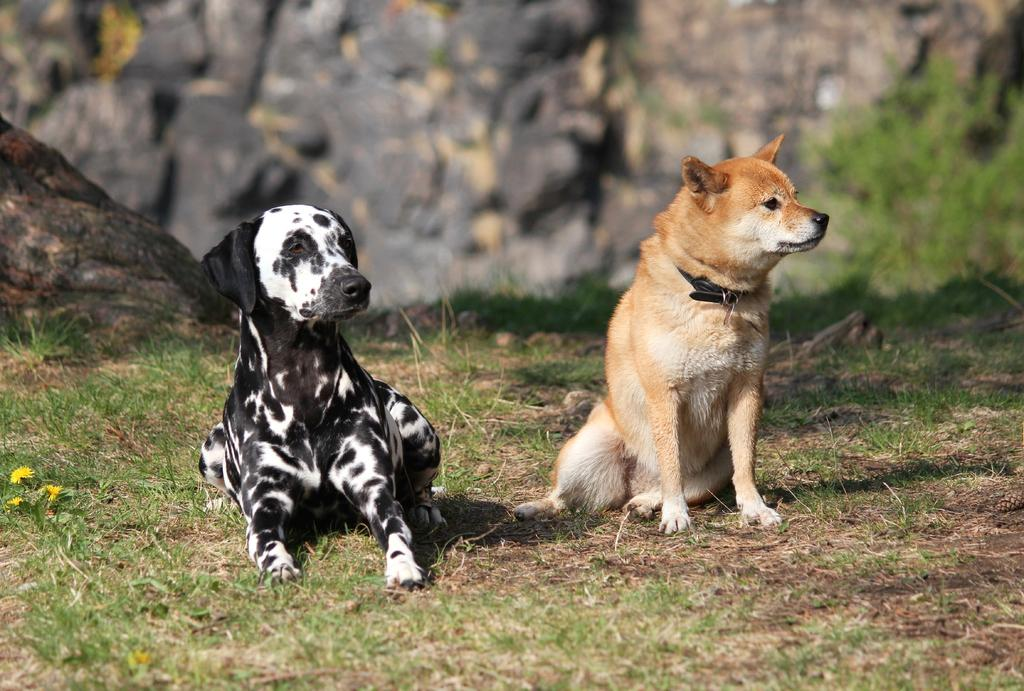How many dogs are in the image? There are two dogs in the image. What are the colors of the dogs? One dog is black, and the other is brown. What is the ground covered with in the image? There is green grass on the ground in the image. What can be seen in the background of the image? There are rocks in the background of the image. What type of business is being conducted by the dogs in the image? There is no business being conducted by the dogs in the image; they are simply dogs in a grassy area with rocks in the background. How many copies of the rocks can be seen in the image? There is only one set of rocks visible in the image, so it is not possible to make copies of them within the image. 